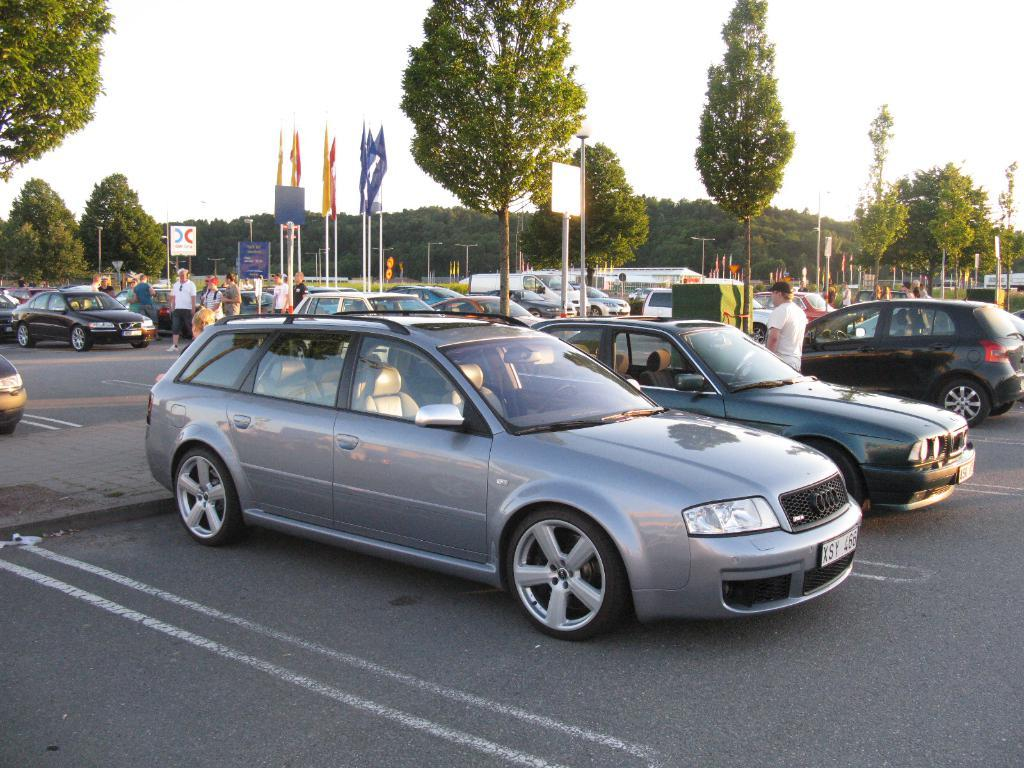What types of objects can be seen in the image? There are vehicles, persons on the ground, flags, and trees in the image. What is visible in the background of the image? The sky is visible in the background of the image. What type of bun is being used as an example in the image? There is no bun present in the image. How is the hose being used in the image? There is no hose present in the image. 